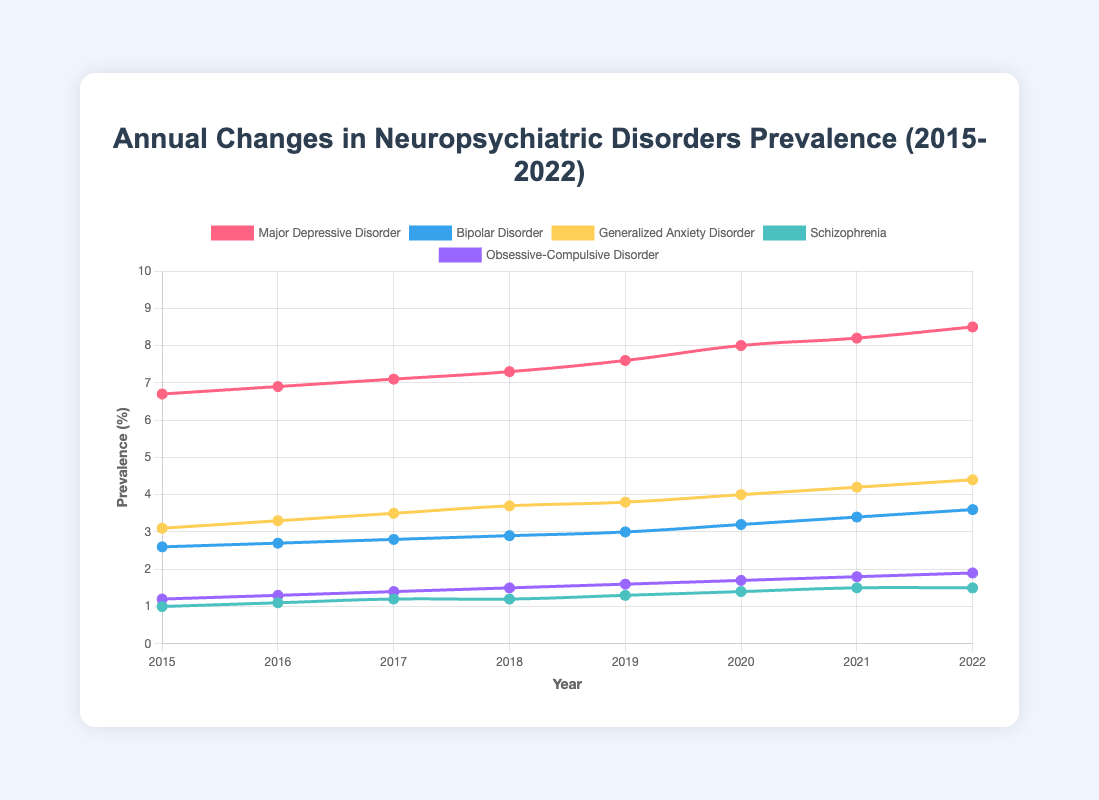What's the prevalence trend of Major Depressive Disorder from 2015 to 2022? The prevalence of Major Depressive Disorder appears to be increasing each year, starting from 6.7% in 2015 and rising consistently to 8.5% in 2022.
Answer: Increasing Which disorder has the highest prevalence in 2022? Observing the height of the lines at the year 2022, Major Depressive Disorder has the highest prevalence at 8.5%.
Answer: Major Depressive Disorder In which year did Bipolar Disorder see the most significant increase in prevalence? The most significant increase can be identified by evaluating the year-to-year changes. From 2019 to 2020, the increase was from 3.0% to 3.2%, which is a change of 0.2%, the most substantial single-year increase.
Answer: 2019-2020 What is the average prevalence of Generalized Anxiety Disorder over the years 2015 to 2022? Summing up the prevalence values from 2015 to 2022: (3.1 + 3.3 + 3.5 + 3.7 + 3.8 + 4.0 + 4.2 + 4.4) = 30.0, the average is 30.0/8 = 3.75%
Answer: 3.75% Compare the prevalence trends of Schizophrenia and Obsessive-Compulsive Disorder from 2015 to 2022. Which disorder shows a larger relative increase? Schizophrenia increased from 1.0% to 1.5%, and Obsessive-Compulsive Disorder from 1.2% to 1.9%. The relative increase for Schizophrenia is (1.5-1.0)/1.0 = 0.5 or 50%, and for OCD it is (1.9-1.2)/1.2 = 0.7 or about 58.3%. OCD shows a larger relative increase.
Answer: Obsessive-Compulsive Disorder What is the total prevalence increase of Bipolar Disorder from 2015 to 2022? The prevalence in 2015 is 2.6% and in 2022 is 3.6%. The total increase is 3.6% - 2.6% = 1.0%.
Answer: 1.0% Which disorder had the smallest change in prevalence between 2021 and 2022? Observing the slight year-to-year changes, Schizophrenia's prevalence remained constant from 2021 to 2022 at 1.5%.
Answer: Schizophrenia What is the difference in prevalence between Major Depressive Disorder and Generalized Anxiety Disorder in 2022? Major Depressive Disorder in 2022 is 8.5%, and Generalized Anxiety Disorder is 4.4%. The difference is 8.5 - 4.4 = 4.1%.
Answer: 4.1% What is the combined prevalence of all disorders in 2020? Summing the prevalence rates for each disorder in 2020: 8.0 (MDD) + 3.2 (BD) + 4.0 (GAD) + 1.4 (Schizophrenia) + 1.7 (OCD) = 18.3%
Answer: 18.3% 